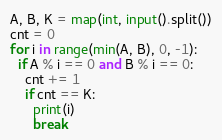Convert code to text. <code><loc_0><loc_0><loc_500><loc_500><_Python_>A, B, K = map(int, input().split())
cnt = 0
for i in range(min(A, B), 0, -1):
  if A % i == 0 and B % i == 0:
    cnt += 1
    if cnt == K:
      print(i)
      break</code> 